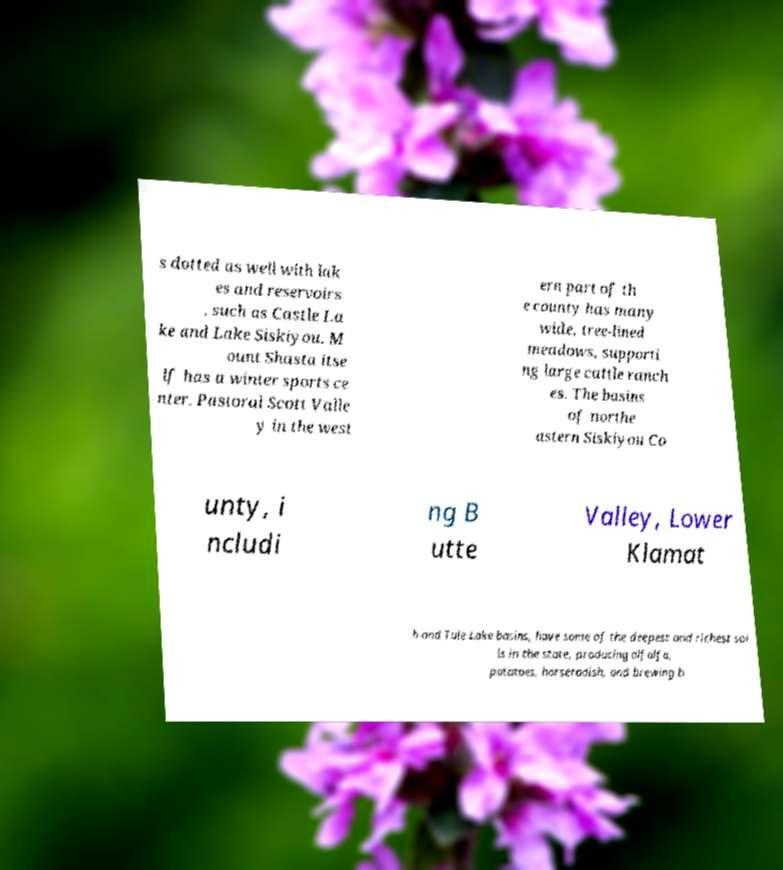There's text embedded in this image that I need extracted. Can you transcribe it verbatim? s dotted as well with lak es and reservoirs , such as Castle La ke and Lake Siskiyou. M ount Shasta itse lf has a winter sports ce nter. Pastoral Scott Valle y in the west ern part of th e county has many wide, tree-lined meadows, supporti ng large cattle ranch es. The basins of northe astern Siskiyou Co unty, i ncludi ng B utte Valley, Lower Klamat h and Tule Lake basins, have some of the deepest and richest soi ls in the state, producing alfalfa, potatoes, horseradish, and brewing b 